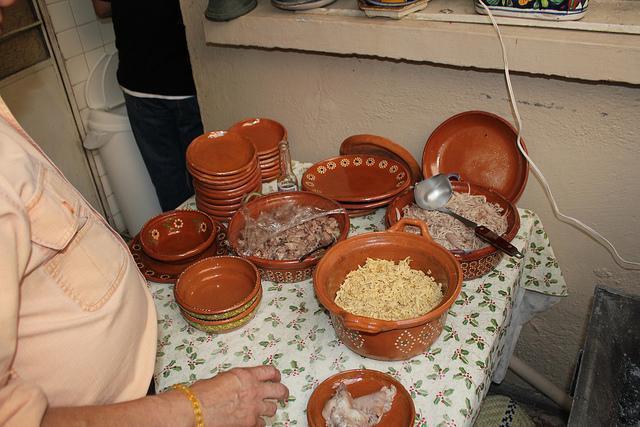Where is this food located?
Answer the question by selecting the correct answer among the 4 following choices and explain your choice with a short sentence. The answer should be formatted with the following format: `Answer: choice
Rationale: rationale.`
Options: Gas station, outside, home kitchen, restaurant. Answer: home kitchen.
Rationale: A woman is standing in front of a table with a dishes on it on top of a plastic tablecloth decorated with holly. 